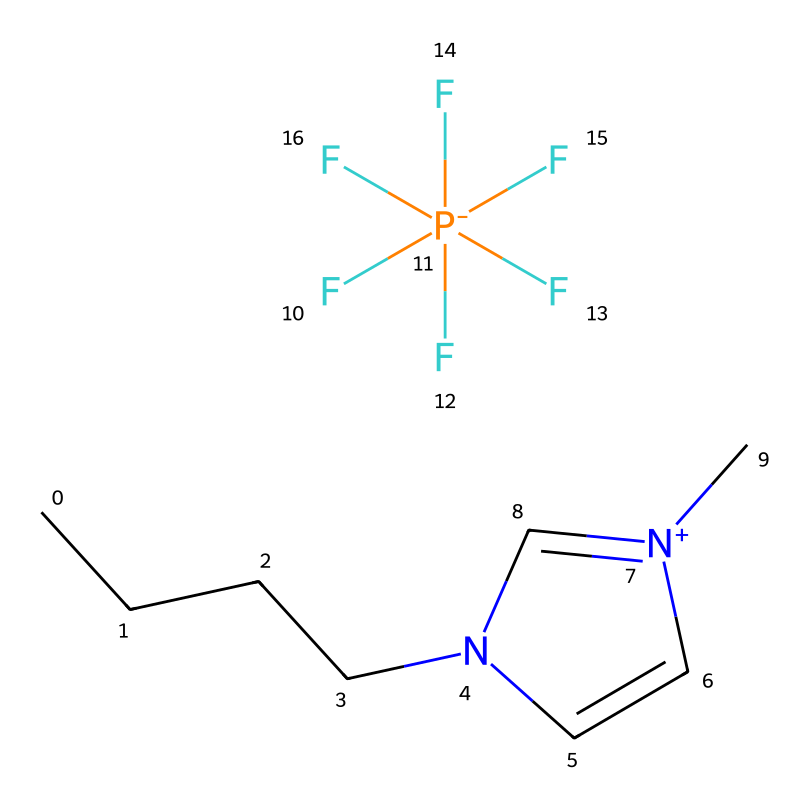how many carbon atoms are present in this ionic liquid? Counting the carbon (C) symbols in the provided SMILES notation, there are five carbon atoms located in the straight-chain portion indicated by 'CCCC' and one more in the cyclic structure, totaling six carbon atoms.
Answer: six what is the charge of the nitrogen in this structure? The nitrogen is represented by 'n+' in the notation, which indicates that it has a positive charge. Therefore, the charge of the nitrogen in this ionic liquid is +1.
Answer: +1 which functional group is identified by the 'F[P-]' part in the SMILES? The 'P-' segment indicates a phosphonium ion where phosphorus (P) carries a negative charge due to its bonding with multiple fluorine atoms indicated by (F)(F)(F)(F)(F) attached to it; this describes a perfluorinated phosphonium ion.
Answer: perfluorinated phosphonium ion what type of bonding is indicated by the presence of the 'n+' in the ring structure? The 'n+' indicates that the nitrogen atom is part of a cyclic structure and exhibits positive charge, which typically implies the presence of coordination or ionic bonding within the ionic liquid framework.
Answer: ionic bonding how many bonds are present between the phosphorus and fluorine atoms? The notation shows that phosphorus is bonded to five fluorine atoms, making a total of five P-F bonds as indicated by the five 'F' symbols connected to 'P'.
Answer: five what is the role of the alkyl chain in this ionic liquid? The alkyl chain represented by 'CCCC' provides hydrophobic characteristics which enhance solubility in organic solvents and stability of the ionic liquid; it contributes to the amphiphilic nature of the ionic liquid.
Answer: hydrophobic characteristics which element in this structure is responsible for the ionic character of the liquid? The element that contributes to the ionic character of the liquid is the phosphorus (P) atom due to its bonding with highly electronegative fluorine atoms, which creates a strong ionic interaction in the liquid.
Answer: phosphorus 